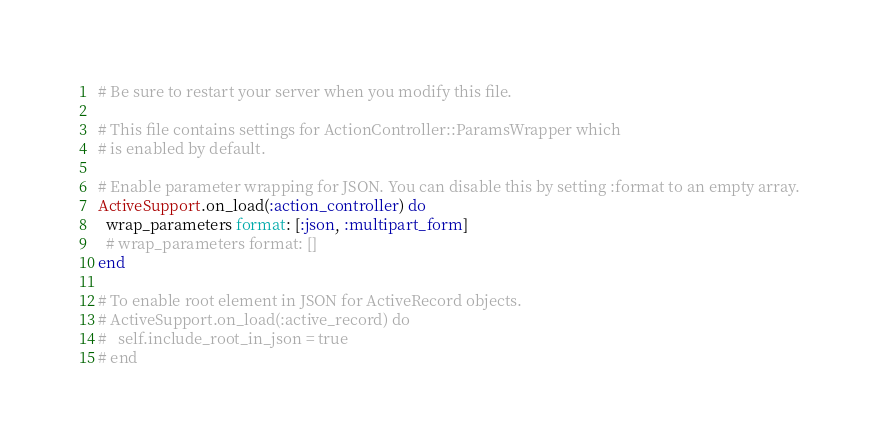<code> <loc_0><loc_0><loc_500><loc_500><_Ruby_># Be sure to restart your server when you modify this file.

# This file contains settings for ActionController::ParamsWrapper which
# is enabled by default.

# Enable parameter wrapping for JSON. You can disable this by setting :format to an empty array.
ActiveSupport.on_load(:action_controller) do
  wrap_parameters format: [:json, :multipart_form]
  # wrap_parameters format: []
end

# To enable root element in JSON for ActiveRecord objects.
# ActiveSupport.on_load(:active_record) do
#   self.include_root_in_json = true
# end
</code> 